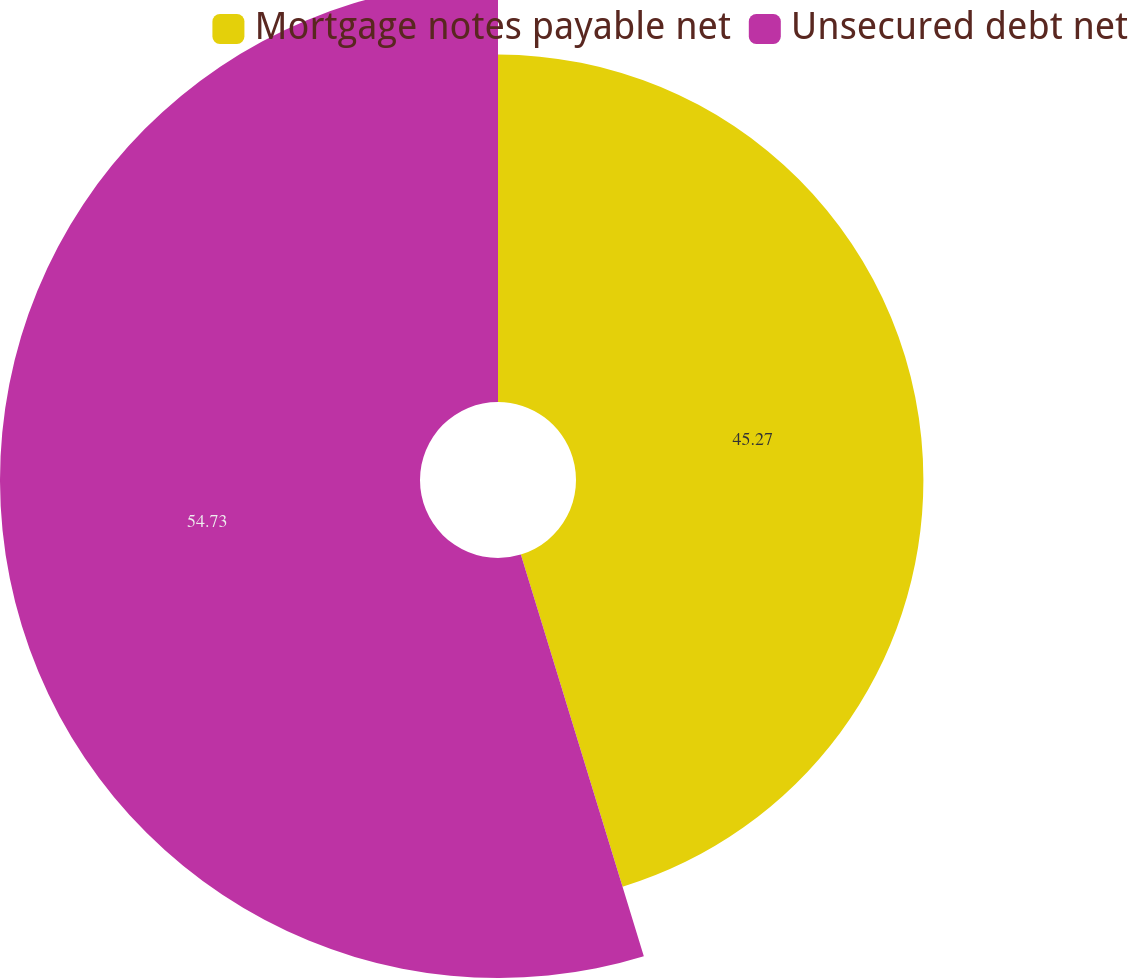Convert chart to OTSL. <chart><loc_0><loc_0><loc_500><loc_500><pie_chart><fcel>Mortgage notes payable net<fcel>Unsecured debt net<nl><fcel>45.27%<fcel>54.73%<nl></chart> 